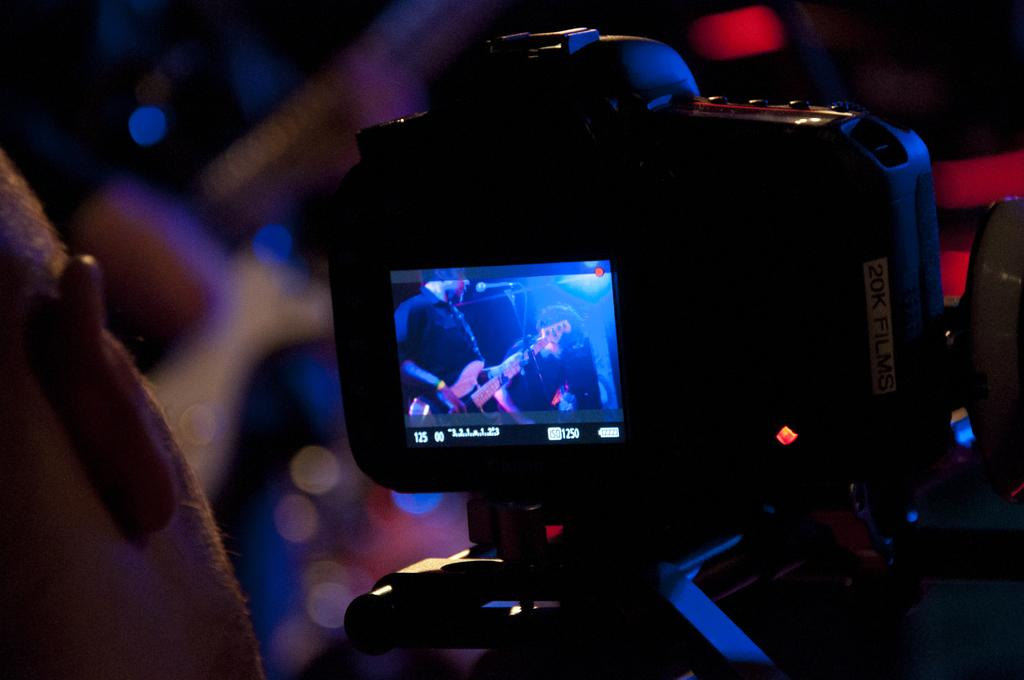What is the person in the image holding? The person in the image is holding a camera. How is the camera positioned in the image? The camera is placed on a stand. What can be seen on the camera screen? The camera screen shows a person with a guitar. What object is placed in front of the person with the guitar? There is a microphone placed in front of the person with the guitar. Are there any snakes present in the image? No, there are no snakes present in the image. 